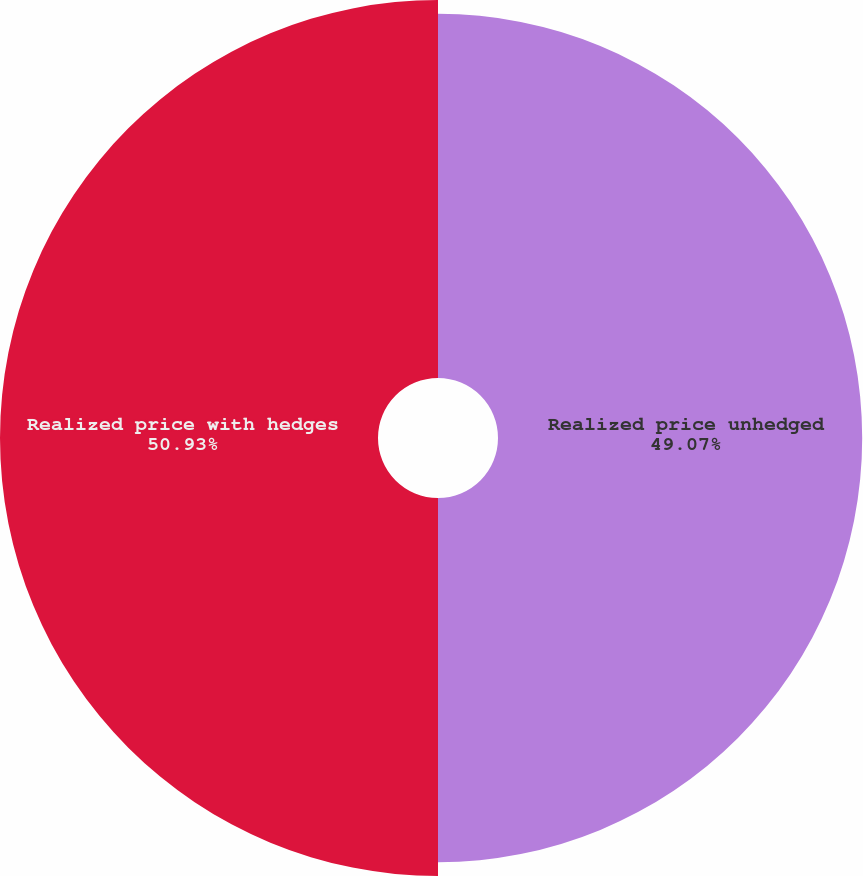<chart> <loc_0><loc_0><loc_500><loc_500><pie_chart><fcel>Realized price unhedged<fcel>Realized price with hedges<nl><fcel>49.07%<fcel>50.93%<nl></chart> 